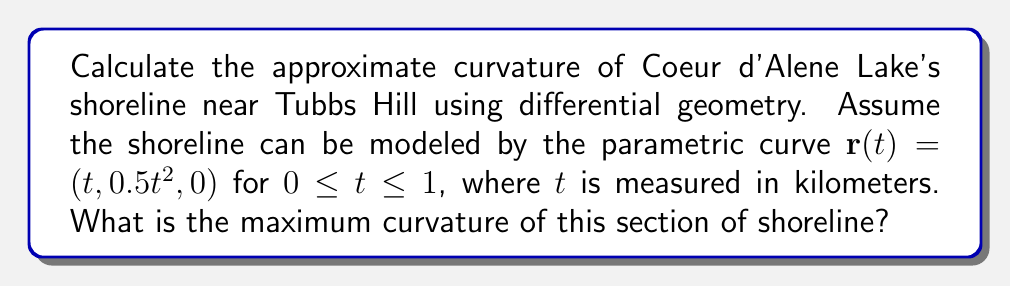Could you help me with this problem? To calculate the curvature of the shoreline, we'll use the formula for the curvature of a parametric curve in 3D space:

$$\kappa = \frac{|\mathbf{r}'(t) \times \mathbf{r}''(t)|}{|\mathbf{r}'(t)|^3}$$

Step 1: Calculate $\mathbf{r}'(t)$ and $\mathbf{r}''(t)$
$\mathbf{r}'(t) = (1, t, 0)$
$\mathbf{r}''(t) = (0, 1, 0)$

Step 2: Calculate the cross product $\mathbf{r}'(t) \times \mathbf{r}''(t)$
$\mathbf{r}'(t) \times \mathbf{r}''(t) = (0, 0, 1)$

Step 3: Calculate the magnitudes
$|\mathbf{r}'(t) \times \mathbf{r}''(t)| = 1$
$|\mathbf{r}'(t)| = \sqrt{1^2 + t^2} = \sqrt{1 + t^2}$

Step 4: Apply the curvature formula
$$\kappa(t) = \frac{1}{(1 + t^2)^{3/2}}$$

Step 5: Find the maximum curvature
The curvature is maximum when $t = 0$, which gives:
$$\kappa_{max} = \kappa(0) = 1$$

Therefore, the maximum curvature of this section of shoreline is 1 km^(-1).
Answer: 1 km^(-1) 